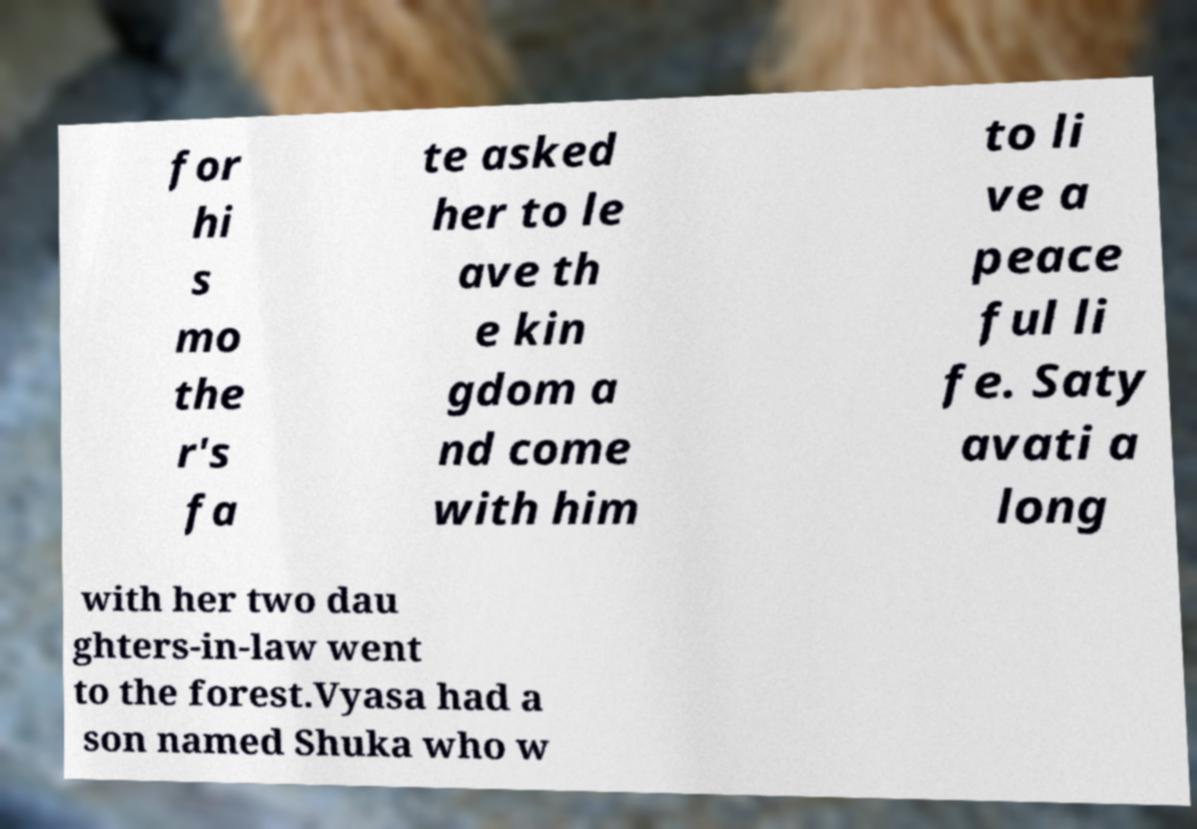Please identify and transcribe the text found in this image. for hi s mo the r's fa te asked her to le ave th e kin gdom a nd come with him to li ve a peace ful li fe. Saty avati a long with her two dau ghters-in-law went to the forest.Vyasa had a son named Shuka who w 